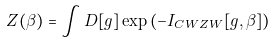<formula> <loc_0><loc_0><loc_500><loc_500>Z ( \beta ) = \int D [ g ] \exp \left ( - I _ { C W Z W } [ g , \beta ] \right )</formula> 